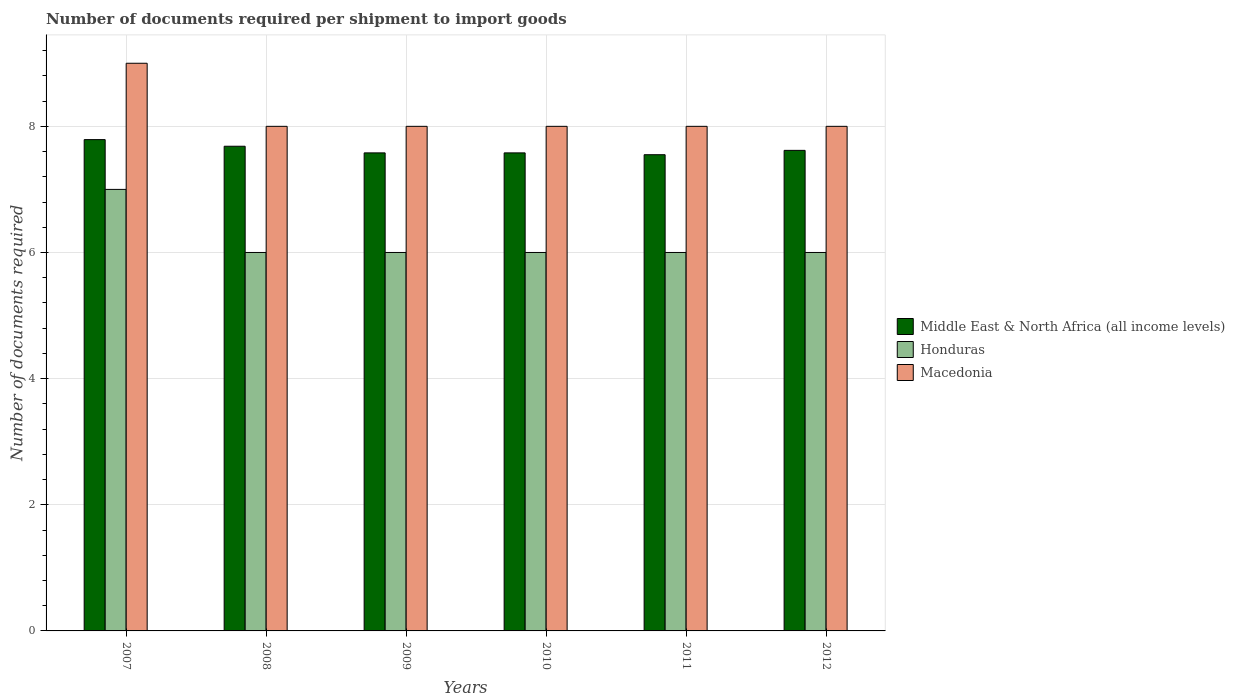How many different coloured bars are there?
Provide a succinct answer. 3. How many groups of bars are there?
Offer a very short reply. 6. Are the number of bars on each tick of the X-axis equal?
Your answer should be very brief. Yes. How many bars are there on the 2nd tick from the right?
Provide a short and direct response. 3. In how many cases, is the number of bars for a given year not equal to the number of legend labels?
Offer a terse response. 0. Across all years, what is the maximum number of documents required per shipment to import goods in Middle East & North Africa (all income levels)?
Give a very brief answer. 7.79. Across all years, what is the minimum number of documents required per shipment to import goods in Macedonia?
Provide a short and direct response. 8. In which year was the number of documents required per shipment to import goods in Middle East & North Africa (all income levels) maximum?
Your answer should be very brief. 2007. What is the total number of documents required per shipment to import goods in Middle East & North Africa (all income levels) in the graph?
Keep it short and to the point. 45.8. What is the difference between the number of documents required per shipment to import goods in Macedonia in 2007 and the number of documents required per shipment to import goods in Honduras in 2010?
Offer a terse response. 3. What is the average number of documents required per shipment to import goods in Middle East & North Africa (all income levels) per year?
Your answer should be very brief. 7.63. In the year 2011, what is the difference between the number of documents required per shipment to import goods in Middle East & North Africa (all income levels) and number of documents required per shipment to import goods in Macedonia?
Your answer should be very brief. -0.45. What is the ratio of the number of documents required per shipment to import goods in Middle East & North Africa (all income levels) in 2011 to that in 2012?
Offer a terse response. 0.99. Is the number of documents required per shipment to import goods in Honduras in 2008 less than that in 2010?
Make the answer very short. No. Is the difference between the number of documents required per shipment to import goods in Middle East & North Africa (all income levels) in 2011 and 2012 greater than the difference between the number of documents required per shipment to import goods in Macedonia in 2011 and 2012?
Make the answer very short. No. What is the difference between the highest and the second highest number of documents required per shipment to import goods in Honduras?
Your answer should be very brief. 1. What is the difference between the highest and the lowest number of documents required per shipment to import goods in Macedonia?
Make the answer very short. 1. In how many years, is the number of documents required per shipment to import goods in Honduras greater than the average number of documents required per shipment to import goods in Honduras taken over all years?
Your answer should be very brief. 1. What does the 3rd bar from the left in 2010 represents?
Your answer should be very brief. Macedonia. What does the 3rd bar from the right in 2008 represents?
Offer a very short reply. Middle East & North Africa (all income levels). Is it the case that in every year, the sum of the number of documents required per shipment to import goods in Middle East & North Africa (all income levels) and number of documents required per shipment to import goods in Macedonia is greater than the number of documents required per shipment to import goods in Honduras?
Give a very brief answer. Yes. How many bars are there?
Give a very brief answer. 18. What is the difference between two consecutive major ticks on the Y-axis?
Give a very brief answer. 2. Are the values on the major ticks of Y-axis written in scientific E-notation?
Your answer should be very brief. No. Does the graph contain any zero values?
Provide a short and direct response. No. Does the graph contain grids?
Your answer should be compact. Yes. Where does the legend appear in the graph?
Your response must be concise. Center right. How many legend labels are there?
Give a very brief answer. 3. How are the legend labels stacked?
Provide a short and direct response. Vertical. What is the title of the graph?
Provide a short and direct response. Number of documents required per shipment to import goods. Does "Liberia" appear as one of the legend labels in the graph?
Your answer should be very brief. No. What is the label or title of the X-axis?
Offer a terse response. Years. What is the label or title of the Y-axis?
Ensure brevity in your answer.  Number of documents required. What is the Number of documents required of Middle East & North Africa (all income levels) in 2007?
Offer a very short reply. 7.79. What is the Number of documents required in Middle East & North Africa (all income levels) in 2008?
Keep it short and to the point. 7.68. What is the Number of documents required of Honduras in 2008?
Ensure brevity in your answer.  6. What is the Number of documents required in Macedonia in 2008?
Your answer should be compact. 8. What is the Number of documents required of Middle East & North Africa (all income levels) in 2009?
Ensure brevity in your answer.  7.58. What is the Number of documents required in Middle East & North Africa (all income levels) in 2010?
Give a very brief answer. 7.58. What is the Number of documents required in Honduras in 2010?
Provide a short and direct response. 6. What is the Number of documents required in Middle East & North Africa (all income levels) in 2011?
Ensure brevity in your answer.  7.55. What is the Number of documents required of Middle East & North Africa (all income levels) in 2012?
Keep it short and to the point. 7.62. What is the Number of documents required in Honduras in 2012?
Your answer should be very brief. 6. What is the Number of documents required of Macedonia in 2012?
Ensure brevity in your answer.  8. Across all years, what is the maximum Number of documents required of Middle East & North Africa (all income levels)?
Keep it short and to the point. 7.79. Across all years, what is the maximum Number of documents required in Honduras?
Your response must be concise. 7. Across all years, what is the maximum Number of documents required in Macedonia?
Offer a terse response. 9. Across all years, what is the minimum Number of documents required in Middle East & North Africa (all income levels)?
Ensure brevity in your answer.  7.55. Across all years, what is the minimum Number of documents required of Macedonia?
Provide a succinct answer. 8. What is the total Number of documents required in Middle East & North Africa (all income levels) in the graph?
Your answer should be compact. 45.8. What is the difference between the Number of documents required of Middle East & North Africa (all income levels) in 2007 and that in 2008?
Ensure brevity in your answer.  0.11. What is the difference between the Number of documents required of Middle East & North Africa (all income levels) in 2007 and that in 2009?
Provide a short and direct response. 0.21. What is the difference between the Number of documents required of Macedonia in 2007 and that in 2009?
Offer a very short reply. 1. What is the difference between the Number of documents required in Middle East & North Africa (all income levels) in 2007 and that in 2010?
Provide a short and direct response. 0.21. What is the difference between the Number of documents required in Honduras in 2007 and that in 2010?
Give a very brief answer. 1. What is the difference between the Number of documents required in Macedonia in 2007 and that in 2010?
Provide a short and direct response. 1. What is the difference between the Number of documents required in Middle East & North Africa (all income levels) in 2007 and that in 2011?
Your answer should be very brief. 0.24. What is the difference between the Number of documents required in Honduras in 2007 and that in 2011?
Your answer should be compact. 1. What is the difference between the Number of documents required in Middle East & North Africa (all income levels) in 2007 and that in 2012?
Give a very brief answer. 0.17. What is the difference between the Number of documents required of Honduras in 2007 and that in 2012?
Offer a terse response. 1. What is the difference between the Number of documents required of Middle East & North Africa (all income levels) in 2008 and that in 2009?
Your answer should be very brief. 0.11. What is the difference between the Number of documents required of Macedonia in 2008 and that in 2009?
Your answer should be very brief. 0. What is the difference between the Number of documents required of Middle East & North Africa (all income levels) in 2008 and that in 2010?
Provide a succinct answer. 0.11. What is the difference between the Number of documents required in Macedonia in 2008 and that in 2010?
Your answer should be very brief. 0. What is the difference between the Number of documents required in Middle East & North Africa (all income levels) in 2008 and that in 2011?
Your answer should be compact. 0.13. What is the difference between the Number of documents required of Macedonia in 2008 and that in 2011?
Provide a short and direct response. 0. What is the difference between the Number of documents required in Middle East & North Africa (all income levels) in 2008 and that in 2012?
Provide a succinct answer. 0.07. What is the difference between the Number of documents required in Middle East & North Africa (all income levels) in 2009 and that in 2010?
Your response must be concise. 0. What is the difference between the Number of documents required in Macedonia in 2009 and that in 2010?
Keep it short and to the point. 0. What is the difference between the Number of documents required of Middle East & North Africa (all income levels) in 2009 and that in 2011?
Your answer should be compact. 0.03. What is the difference between the Number of documents required in Honduras in 2009 and that in 2011?
Your answer should be compact. 0. What is the difference between the Number of documents required of Middle East & North Africa (all income levels) in 2009 and that in 2012?
Your answer should be compact. -0.04. What is the difference between the Number of documents required in Middle East & North Africa (all income levels) in 2010 and that in 2011?
Your answer should be compact. 0.03. What is the difference between the Number of documents required in Honduras in 2010 and that in 2011?
Your response must be concise. 0. What is the difference between the Number of documents required of Macedonia in 2010 and that in 2011?
Keep it short and to the point. 0. What is the difference between the Number of documents required of Middle East & North Africa (all income levels) in 2010 and that in 2012?
Offer a very short reply. -0.04. What is the difference between the Number of documents required in Macedonia in 2010 and that in 2012?
Keep it short and to the point. 0. What is the difference between the Number of documents required of Middle East & North Africa (all income levels) in 2011 and that in 2012?
Offer a very short reply. -0.07. What is the difference between the Number of documents required in Honduras in 2011 and that in 2012?
Offer a very short reply. 0. What is the difference between the Number of documents required in Macedonia in 2011 and that in 2012?
Offer a very short reply. 0. What is the difference between the Number of documents required in Middle East & North Africa (all income levels) in 2007 and the Number of documents required in Honduras in 2008?
Provide a short and direct response. 1.79. What is the difference between the Number of documents required of Middle East & North Africa (all income levels) in 2007 and the Number of documents required of Macedonia in 2008?
Your answer should be compact. -0.21. What is the difference between the Number of documents required of Middle East & North Africa (all income levels) in 2007 and the Number of documents required of Honduras in 2009?
Offer a very short reply. 1.79. What is the difference between the Number of documents required of Middle East & North Africa (all income levels) in 2007 and the Number of documents required of Macedonia in 2009?
Make the answer very short. -0.21. What is the difference between the Number of documents required in Middle East & North Africa (all income levels) in 2007 and the Number of documents required in Honduras in 2010?
Offer a terse response. 1.79. What is the difference between the Number of documents required of Middle East & North Africa (all income levels) in 2007 and the Number of documents required of Macedonia in 2010?
Make the answer very short. -0.21. What is the difference between the Number of documents required in Middle East & North Africa (all income levels) in 2007 and the Number of documents required in Honduras in 2011?
Provide a short and direct response. 1.79. What is the difference between the Number of documents required of Middle East & North Africa (all income levels) in 2007 and the Number of documents required of Macedonia in 2011?
Offer a terse response. -0.21. What is the difference between the Number of documents required in Honduras in 2007 and the Number of documents required in Macedonia in 2011?
Your answer should be very brief. -1. What is the difference between the Number of documents required in Middle East & North Africa (all income levels) in 2007 and the Number of documents required in Honduras in 2012?
Give a very brief answer. 1.79. What is the difference between the Number of documents required in Middle East & North Africa (all income levels) in 2007 and the Number of documents required in Macedonia in 2012?
Your response must be concise. -0.21. What is the difference between the Number of documents required of Honduras in 2007 and the Number of documents required of Macedonia in 2012?
Ensure brevity in your answer.  -1. What is the difference between the Number of documents required in Middle East & North Africa (all income levels) in 2008 and the Number of documents required in Honduras in 2009?
Provide a succinct answer. 1.68. What is the difference between the Number of documents required in Middle East & North Africa (all income levels) in 2008 and the Number of documents required in Macedonia in 2009?
Your answer should be compact. -0.32. What is the difference between the Number of documents required in Middle East & North Africa (all income levels) in 2008 and the Number of documents required in Honduras in 2010?
Offer a very short reply. 1.68. What is the difference between the Number of documents required of Middle East & North Africa (all income levels) in 2008 and the Number of documents required of Macedonia in 2010?
Your answer should be compact. -0.32. What is the difference between the Number of documents required in Middle East & North Africa (all income levels) in 2008 and the Number of documents required in Honduras in 2011?
Offer a very short reply. 1.68. What is the difference between the Number of documents required in Middle East & North Africa (all income levels) in 2008 and the Number of documents required in Macedonia in 2011?
Give a very brief answer. -0.32. What is the difference between the Number of documents required of Middle East & North Africa (all income levels) in 2008 and the Number of documents required of Honduras in 2012?
Provide a short and direct response. 1.68. What is the difference between the Number of documents required in Middle East & North Africa (all income levels) in 2008 and the Number of documents required in Macedonia in 2012?
Keep it short and to the point. -0.32. What is the difference between the Number of documents required of Honduras in 2008 and the Number of documents required of Macedonia in 2012?
Ensure brevity in your answer.  -2. What is the difference between the Number of documents required of Middle East & North Africa (all income levels) in 2009 and the Number of documents required of Honduras in 2010?
Offer a very short reply. 1.58. What is the difference between the Number of documents required of Middle East & North Africa (all income levels) in 2009 and the Number of documents required of Macedonia in 2010?
Your response must be concise. -0.42. What is the difference between the Number of documents required in Middle East & North Africa (all income levels) in 2009 and the Number of documents required in Honduras in 2011?
Ensure brevity in your answer.  1.58. What is the difference between the Number of documents required in Middle East & North Africa (all income levels) in 2009 and the Number of documents required in Macedonia in 2011?
Your answer should be compact. -0.42. What is the difference between the Number of documents required in Honduras in 2009 and the Number of documents required in Macedonia in 2011?
Provide a succinct answer. -2. What is the difference between the Number of documents required of Middle East & North Africa (all income levels) in 2009 and the Number of documents required of Honduras in 2012?
Give a very brief answer. 1.58. What is the difference between the Number of documents required in Middle East & North Africa (all income levels) in 2009 and the Number of documents required in Macedonia in 2012?
Offer a very short reply. -0.42. What is the difference between the Number of documents required in Honduras in 2009 and the Number of documents required in Macedonia in 2012?
Make the answer very short. -2. What is the difference between the Number of documents required in Middle East & North Africa (all income levels) in 2010 and the Number of documents required in Honduras in 2011?
Your answer should be very brief. 1.58. What is the difference between the Number of documents required in Middle East & North Africa (all income levels) in 2010 and the Number of documents required in Macedonia in 2011?
Make the answer very short. -0.42. What is the difference between the Number of documents required of Middle East & North Africa (all income levels) in 2010 and the Number of documents required of Honduras in 2012?
Make the answer very short. 1.58. What is the difference between the Number of documents required of Middle East & North Africa (all income levels) in 2010 and the Number of documents required of Macedonia in 2012?
Give a very brief answer. -0.42. What is the difference between the Number of documents required in Middle East & North Africa (all income levels) in 2011 and the Number of documents required in Honduras in 2012?
Offer a very short reply. 1.55. What is the difference between the Number of documents required in Middle East & North Africa (all income levels) in 2011 and the Number of documents required in Macedonia in 2012?
Ensure brevity in your answer.  -0.45. What is the average Number of documents required of Middle East & North Africa (all income levels) per year?
Keep it short and to the point. 7.63. What is the average Number of documents required in Honduras per year?
Offer a terse response. 6.17. What is the average Number of documents required in Macedonia per year?
Your response must be concise. 8.17. In the year 2007, what is the difference between the Number of documents required of Middle East & North Africa (all income levels) and Number of documents required of Honduras?
Offer a very short reply. 0.79. In the year 2007, what is the difference between the Number of documents required of Middle East & North Africa (all income levels) and Number of documents required of Macedonia?
Your answer should be very brief. -1.21. In the year 2008, what is the difference between the Number of documents required in Middle East & North Africa (all income levels) and Number of documents required in Honduras?
Ensure brevity in your answer.  1.68. In the year 2008, what is the difference between the Number of documents required of Middle East & North Africa (all income levels) and Number of documents required of Macedonia?
Your answer should be very brief. -0.32. In the year 2009, what is the difference between the Number of documents required of Middle East & North Africa (all income levels) and Number of documents required of Honduras?
Provide a succinct answer. 1.58. In the year 2009, what is the difference between the Number of documents required of Middle East & North Africa (all income levels) and Number of documents required of Macedonia?
Your response must be concise. -0.42. In the year 2010, what is the difference between the Number of documents required in Middle East & North Africa (all income levels) and Number of documents required in Honduras?
Offer a very short reply. 1.58. In the year 2010, what is the difference between the Number of documents required in Middle East & North Africa (all income levels) and Number of documents required in Macedonia?
Ensure brevity in your answer.  -0.42. In the year 2010, what is the difference between the Number of documents required in Honduras and Number of documents required in Macedonia?
Make the answer very short. -2. In the year 2011, what is the difference between the Number of documents required in Middle East & North Africa (all income levels) and Number of documents required in Honduras?
Offer a terse response. 1.55. In the year 2011, what is the difference between the Number of documents required in Middle East & North Africa (all income levels) and Number of documents required in Macedonia?
Keep it short and to the point. -0.45. In the year 2012, what is the difference between the Number of documents required of Middle East & North Africa (all income levels) and Number of documents required of Honduras?
Ensure brevity in your answer.  1.62. In the year 2012, what is the difference between the Number of documents required of Middle East & North Africa (all income levels) and Number of documents required of Macedonia?
Make the answer very short. -0.38. What is the ratio of the Number of documents required of Middle East & North Africa (all income levels) in 2007 to that in 2008?
Your answer should be compact. 1.01. What is the ratio of the Number of documents required in Honduras in 2007 to that in 2008?
Your response must be concise. 1.17. What is the ratio of the Number of documents required in Middle East & North Africa (all income levels) in 2007 to that in 2009?
Your answer should be compact. 1.03. What is the ratio of the Number of documents required in Middle East & North Africa (all income levels) in 2007 to that in 2010?
Your answer should be very brief. 1.03. What is the ratio of the Number of documents required of Middle East & North Africa (all income levels) in 2007 to that in 2011?
Provide a succinct answer. 1.03. What is the ratio of the Number of documents required in Honduras in 2007 to that in 2011?
Provide a short and direct response. 1.17. What is the ratio of the Number of documents required in Middle East & North Africa (all income levels) in 2007 to that in 2012?
Offer a terse response. 1.02. What is the ratio of the Number of documents required in Macedonia in 2007 to that in 2012?
Your response must be concise. 1.12. What is the ratio of the Number of documents required in Middle East & North Africa (all income levels) in 2008 to that in 2009?
Keep it short and to the point. 1.01. What is the ratio of the Number of documents required of Honduras in 2008 to that in 2009?
Provide a succinct answer. 1. What is the ratio of the Number of documents required of Middle East & North Africa (all income levels) in 2008 to that in 2010?
Your answer should be very brief. 1.01. What is the ratio of the Number of documents required of Honduras in 2008 to that in 2010?
Your answer should be compact. 1. What is the ratio of the Number of documents required in Macedonia in 2008 to that in 2010?
Your answer should be compact. 1. What is the ratio of the Number of documents required in Middle East & North Africa (all income levels) in 2008 to that in 2011?
Provide a short and direct response. 1.02. What is the ratio of the Number of documents required in Macedonia in 2008 to that in 2011?
Your answer should be very brief. 1. What is the ratio of the Number of documents required of Middle East & North Africa (all income levels) in 2008 to that in 2012?
Make the answer very short. 1.01. What is the ratio of the Number of documents required in Middle East & North Africa (all income levels) in 2009 to that in 2010?
Ensure brevity in your answer.  1. What is the ratio of the Number of documents required in Macedonia in 2009 to that in 2010?
Make the answer very short. 1. What is the ratio of the Number of documents required in Middle East & North Africa (all income levels) in 2009 to that in 2011?
Offer a very short reply. 1. What is the ratio of the Number of documents required in Macedonia in 2009 to that in 2011?
Ensure brevity in your answer.  1. What is the ratio of the Number of documents required of Middle East & North Africa (all income levels) in 2010 to that in 2011?
Provide a short and direct response. 1. What is the ratio of the Number of documents required of Macedonia in 2010 to that in 2011?
Offer a terse response. 1. What is the ratio of the Number of documents required of Middle East & North Africa (all income levels) in 2010 to that in 2012?
Keep it short and to the point. 0.99. What is the ratio of the Number of documents required of Honduras in 2010 to that in 2012?
Give a very brief answer. 1. What is the ratio of the Number of documents required of Middle East & North Africa (all income levels) in 2011 to that in 2012?
Your answer should be compact. 0.99. What is the ratio of the Number of documents required of Honduras in 2011 to that in 2012?
Provide a succinct answer. 1. What is the difference between the highest and the second highest Number of documents required in Middle East & North Africa (all income levels)?
Your answer should be very brief. 0.11. What is the difference between the highest and the second highest Number of documents required of Honduras?
Offer a very short reply. 1. What is the difference between the highest and the second highest Number of documents required of Macedonia?
Keep it short and to the point. 1. What is the difference between the highest and the lowest Number of documents required of Middle East & North Africa (all income levels)?
Provide a short and direct response. 0.24. What is the difference between the highest and the lowest Number of documents required of Honduras?
Make the answer very short. 1. What is the difference between the highest and the lowest Number of documents required in Macedonia?
Provide a succinct answer. 1. 